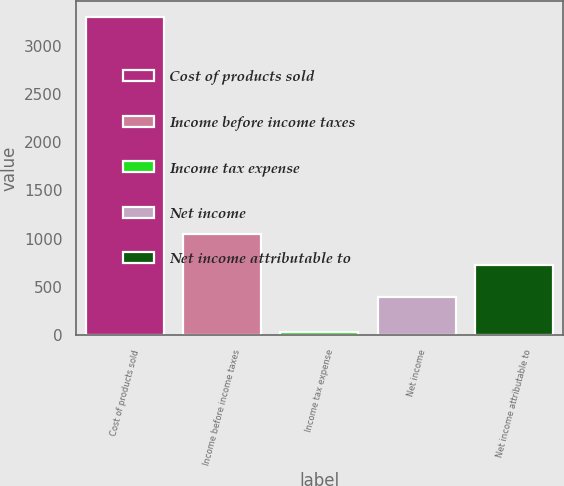Convert chart. <chart><loc_0><loc_0><loc_500><loc_500><bar_chart><fcel>Cost of products sold<fcel>Income before income taxes<fcel>Income tax expense<fcel>Net income<fcel>Net income attributable to<nl><fcel>3294<fcel>1052.2<fcel>38<fcel>401<fcel>726.6<nl></chart> 